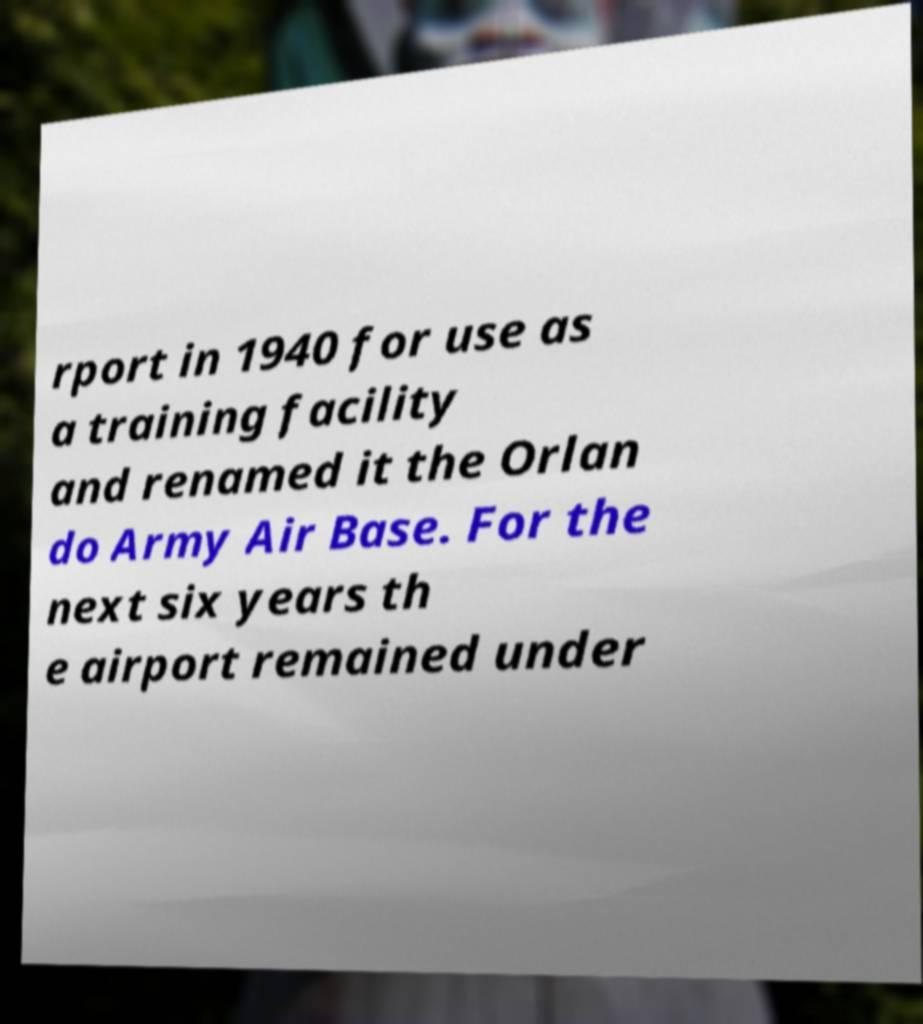Can you read and provide the text displayed in the image?This photo seems to have some interesting text. Can you extract and type it out for me? rport in 1940 for use as a training facility and renamed it the Orlan do Army Air Base. For the next six years th e airport remained under 